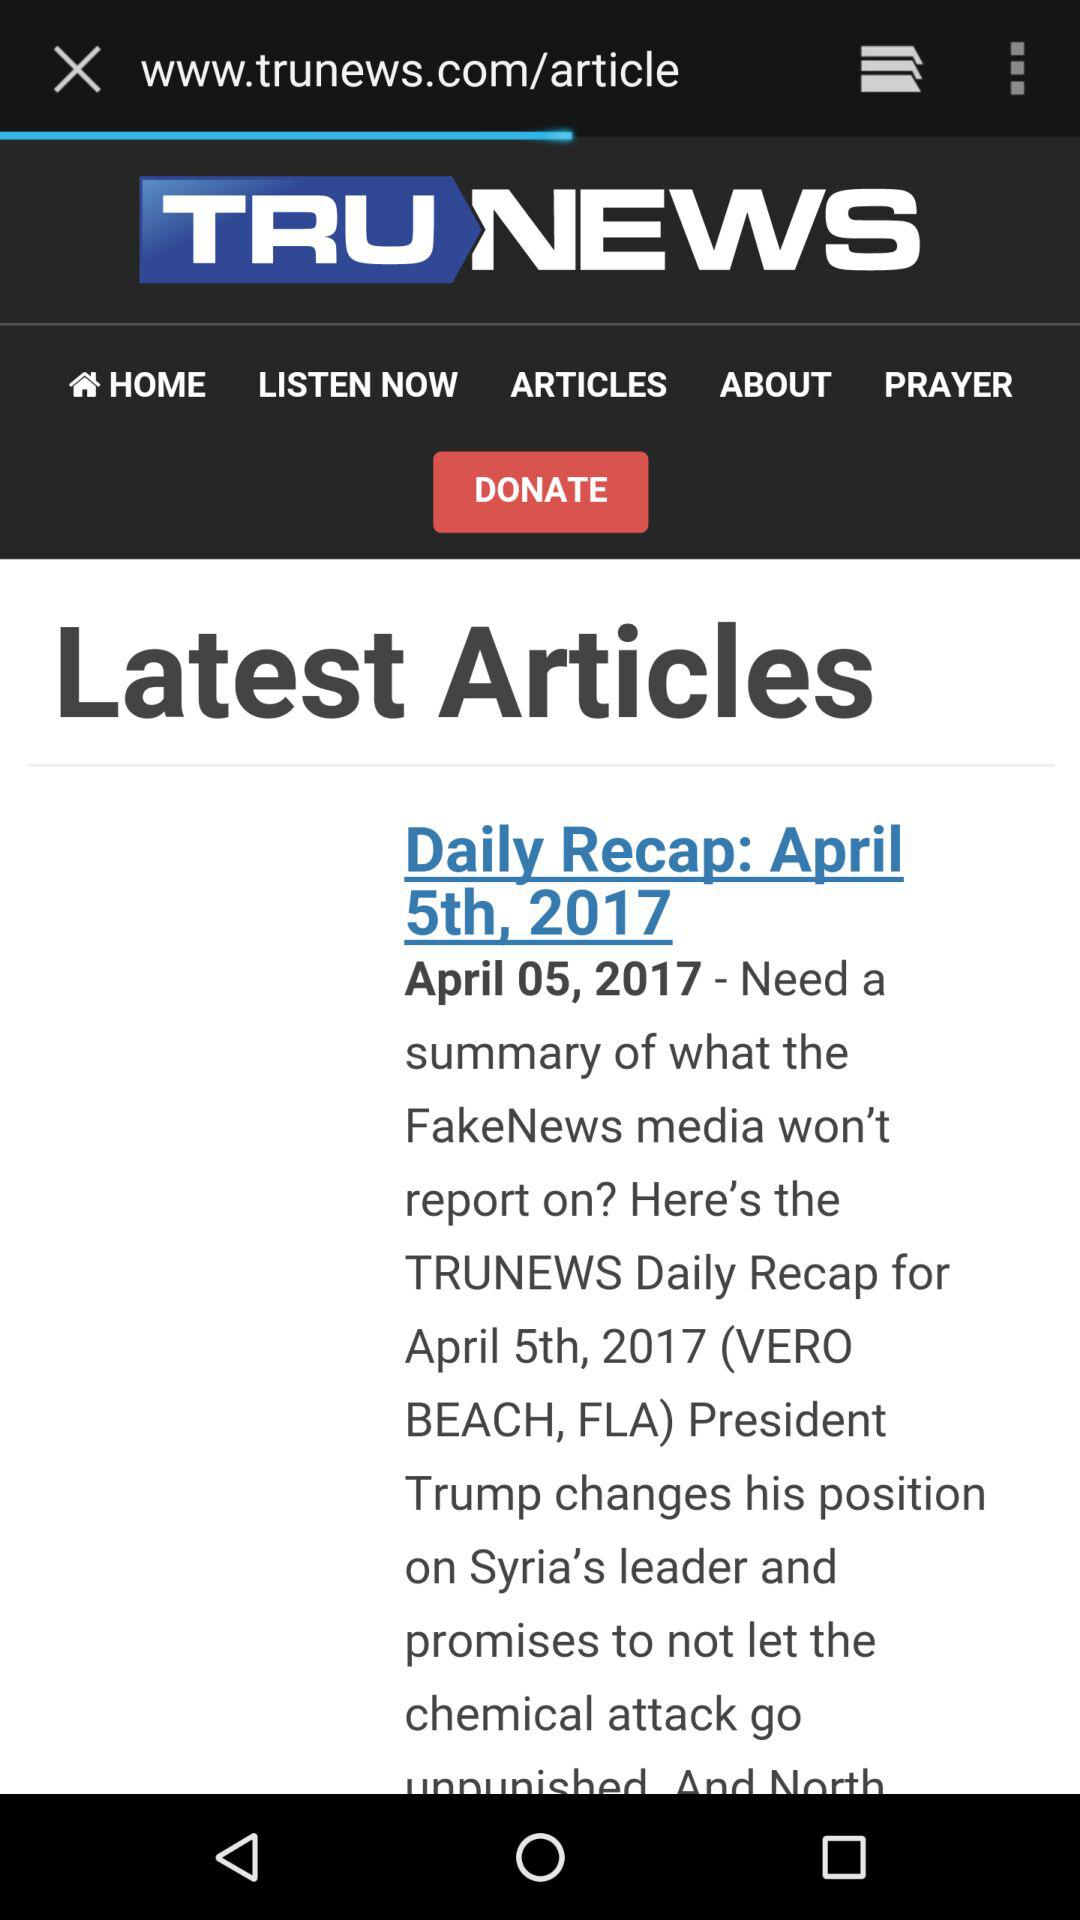What month was this news published? It was published on April month. 